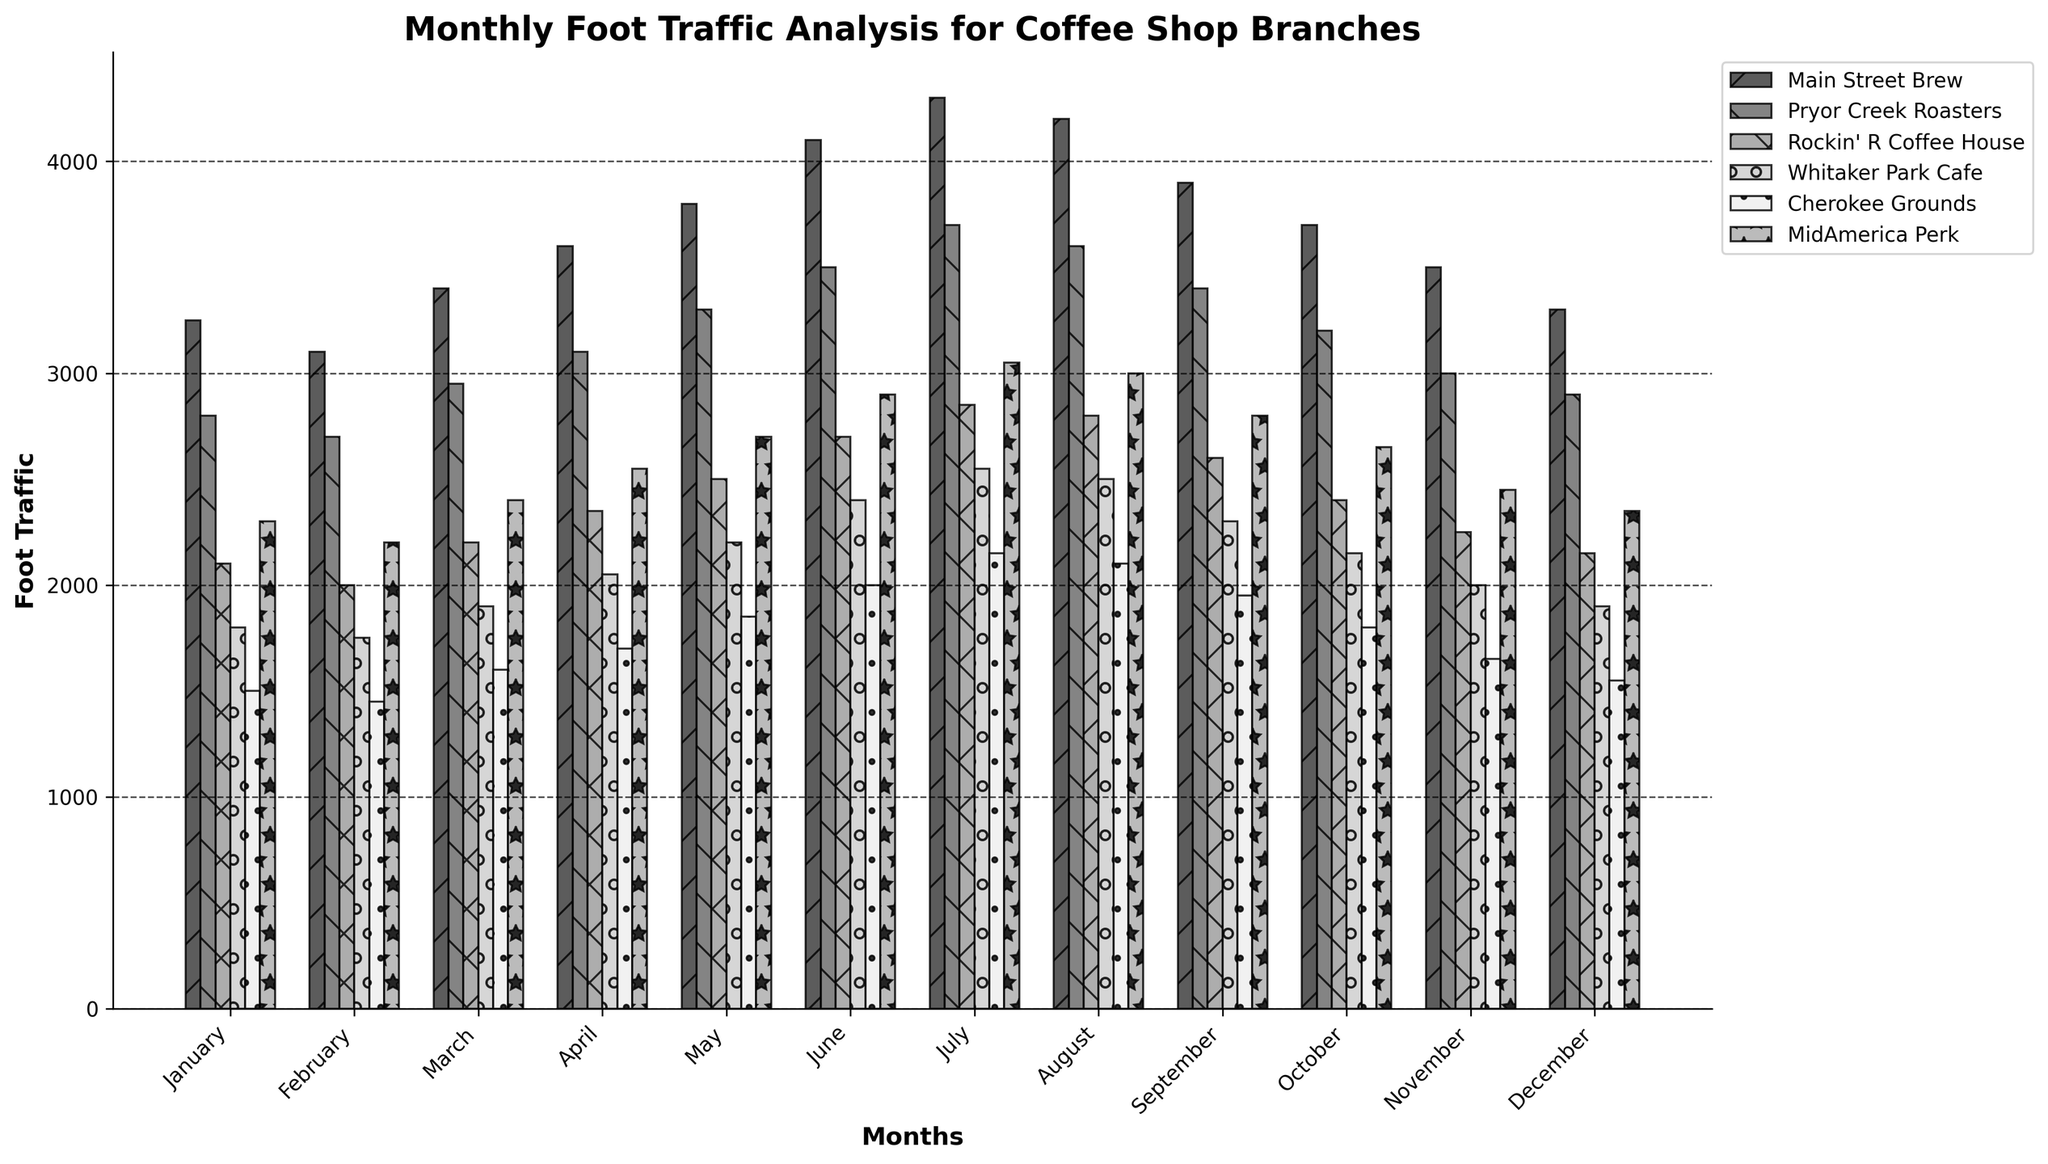Which branch has the highest foot traffic in July? The bar representing July's data for each branch is compared. The tallest bar corresponds to Main Street Brew.
Answer: Main Street Brew What is the total foot traffic for Whitaker Park Cafe from January to December? Sum the values for Whitaker Park Cafe: 1800 (Jan) + 1750 (Feb) + 1900 (Mar) + 2050 (Apr) + 2200 (May) + 2400 (Jun) + 2550 (Jul) + 2500 (Aug) + 2300 (Sep) + 2150 (Oct) + 2000 (Nov) + 1900 (Dec) = 25500.
Answer: 25500 Which month has the lowest foot traffic across all branches? Examine the bars for each month and identify the shortest one. All branches have the lowest foot traffic in February.
Answer: February Is there a month where MidAmerica Perk has higher foot traffic than Main Street Brew? Compare the bars representing MidAmerica Perk and Main Street Brew for each month. MidAmerica Perk never surpasses Main Street Brew in foot traffic in any month.
Answer: No How does Cherokee Grounds' foot traffic change from January to June? Observe the bars for Cherokee Grounds from January to June: The heights increase progressively from 1500 (Jan) to 2000 (Jun).
Answer: Increases Which branch has the most consistent foot traffic throughout the year? Compare the height variations of the bars for each branch. Rockin' R Coffee House shows relatively consistent foot traffic with minor variations.
Answer: Rockin' R Coffee House What is the average foot traffic for Main Street Brew in the first quarter (January-March)? Sum up foot traffic for January, February, and March: 3250 (Jan) + 3100 (Feb) + 3400 (Mar) = 9750. The average is 9750 / 3 = 3250.
Answer: 3250 Which branch shows the greatest increase in foot traffic from January to December? For each branch, subtract the January value from the December value: Main Street Brew (3300-3250), Pryor Creek Roasters (2900-2800), Rockin' R Coffee House (2150-2100), Whitaker Park Cafe (1900-1800), Cherokee Grounds (1550-1500), MidAmerica Perk (2350-2300). Main Street Brew has the largest increase with an increase of 50.
Answer: Main Street Brew Are there any months when Whitaker Park Cafe has a higher foot traffic than Cherokee Grounds? Compare the bars for Whitaker Park Cafe and Cherokee Grounds for each month. In every month, Whitaker Park Cafe has higher or equal foot traffic compared to Cherokee Grounds.
Answer: Yes What is the difference in foot traffic between the branch with the highest and lowest foot traffic in October? In October, Main Street Brew has the highest foot traffic (3700) and Cherokee Grounds has the lowest foot traffic (1800). The difference is 3700 - 1800 = 1900.
Answer: 1900 